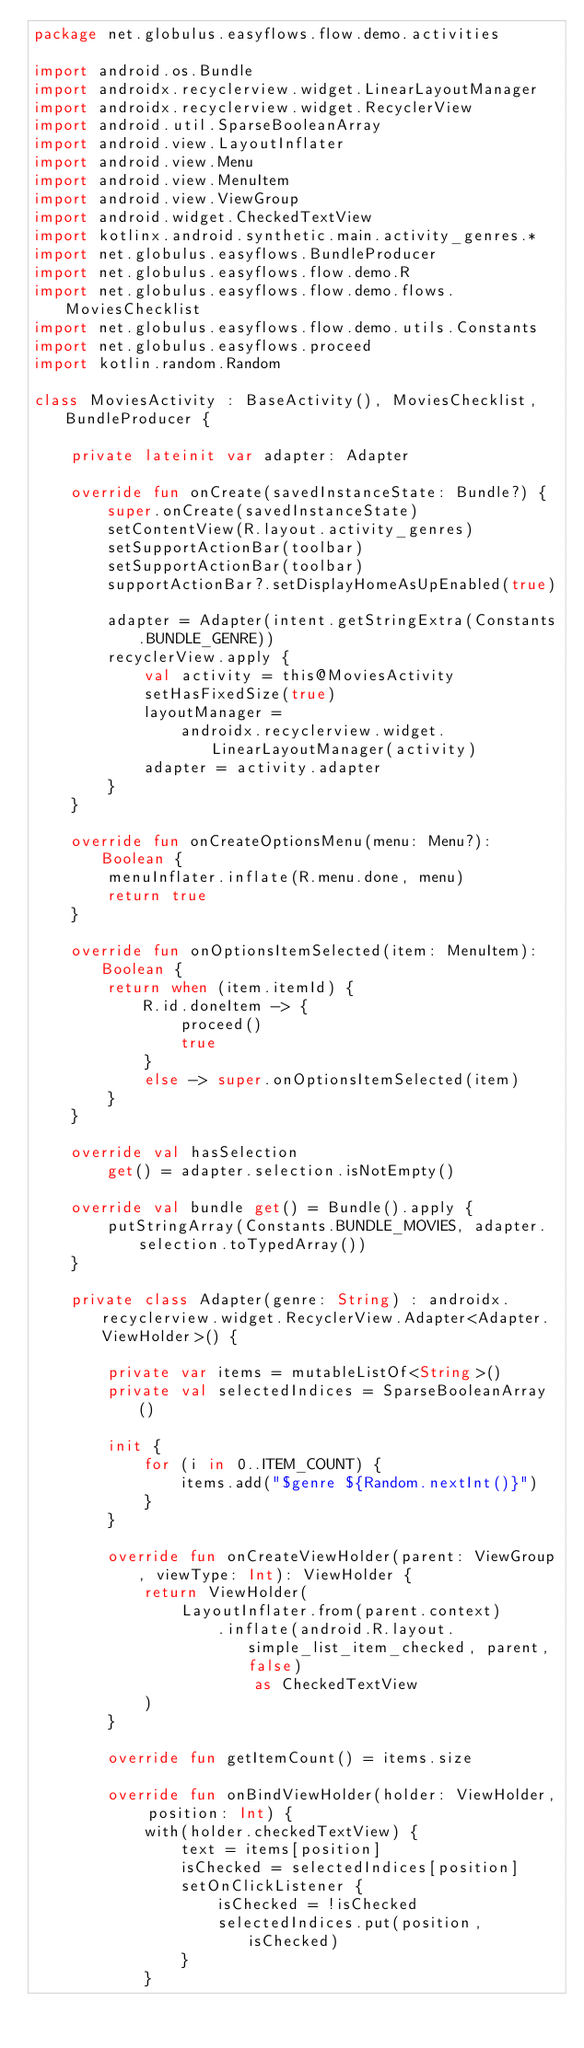Convert code to text. <code><loc_0><loc_0><loc_500><loc_500><_Kotlin_>package net.globulus.easyflows.flow.demo.activities

import android.os.Bundle
import androidx.recyclerview.widget.LinearLayoutManager
import androidx.recyclerview.widget.RecyclerView
import android.util.SparseBooleanArray
import android.view.LayoutInflater
import android.view.Menu
import android.view.MenuItem
import android.view.ViewGroup
import android.widget.CheckedTextView
import kotlinx.android.synthetic.main.activity_genres.*
import net.globulus.easyflows.BundleProducer
import net.globulus.easyflows.flow.demo.R
import net.globulus.easyflows.flow.demo.flows.MoviesChecklist
import net.globulus.easyflows.flow.demo.utils.Constants
import net.globulus.easyflows.proceed
import kotlin.random.Random

class MoviesActivity : BaseActivity(), MoviesChecklist, BundleProducer {

    private lateinit var adapter: Adapter

    override fun onCreate(savedInstanceState: Bundle?) {
        super.onCreate(savedInstanceState)
        setContentView(R.layout.activity_genres)
        setSupportActionBar(toolbar)
        setSupportActionBar(toolbar)
        supportActionBar?.setDisplayHomeAsUpEnabled(true)

        adapter = Adapter(intent.getStringExtra(Constants.BUNDLE_GENRE))
        recyclerView.apply {
            val activity = this@MoviesActivity
            setHasFixedSize(true)
            layoutManager =
                androidx.recyclerview.widget.LinearLayoutManager(activity)
            adapter = activity.adapter
        }
    }

    override fun onCreateOptionsMenu(menu: Menu?): Boolean {
        menuInflater.inflate(R.menu.done, menu)
        return true
    }

    override fun onOptionsItemSelected(item: MenuItem): Boolean {
        return when (item.itemId) {
            R.id.doneItem -> {
                proceed()
                true
            }
            else -> super.onOptionsItemSelected(item)
        }
    }

    override val hasSelection
        get() = adapter.selection.isNotEmpty()

    override val bundle get() = Bundle().apply {
        putStringArray(Constants.BUNDLE_MOVIES, adapter.selection.toTypedArray())
    }

    private class Adapter(genre: String) : androidx.recyclerview.widget.RecyclerView.Adapter<Adapter.ViewHolder>() {

        private var items = mutableListOf<String>()
        private val selectedIndices = SparseBooleanArray()

        init {
            for (i in 0..ITEM_COUNT) {
                items.add("$genre ${Random.nextInt()}")
            }
        }

        override fun onCreateViewHolder(parent: ViewGroup, viewType: Int): ViewHolder {
            return ViewHolder(
                LayoutInflater.from(parent.context)
                    .inflate(android.R.layout.simple_list_item_checked, parent, false)
                        as CheckedTextView
            )
        }

        override fun getItemCount() = items.size

        override fun onBindViewHolder(holder: ViewHolder, position: Int) {
            with(holder.checkedTextView) {
                text = items[position]
                isChecked = selectedIndices[position]
                setOnClickListener {
                    isChecked = !isChecked
                    selectedIndices.put(position, isChecked)
                }
            }</code> 